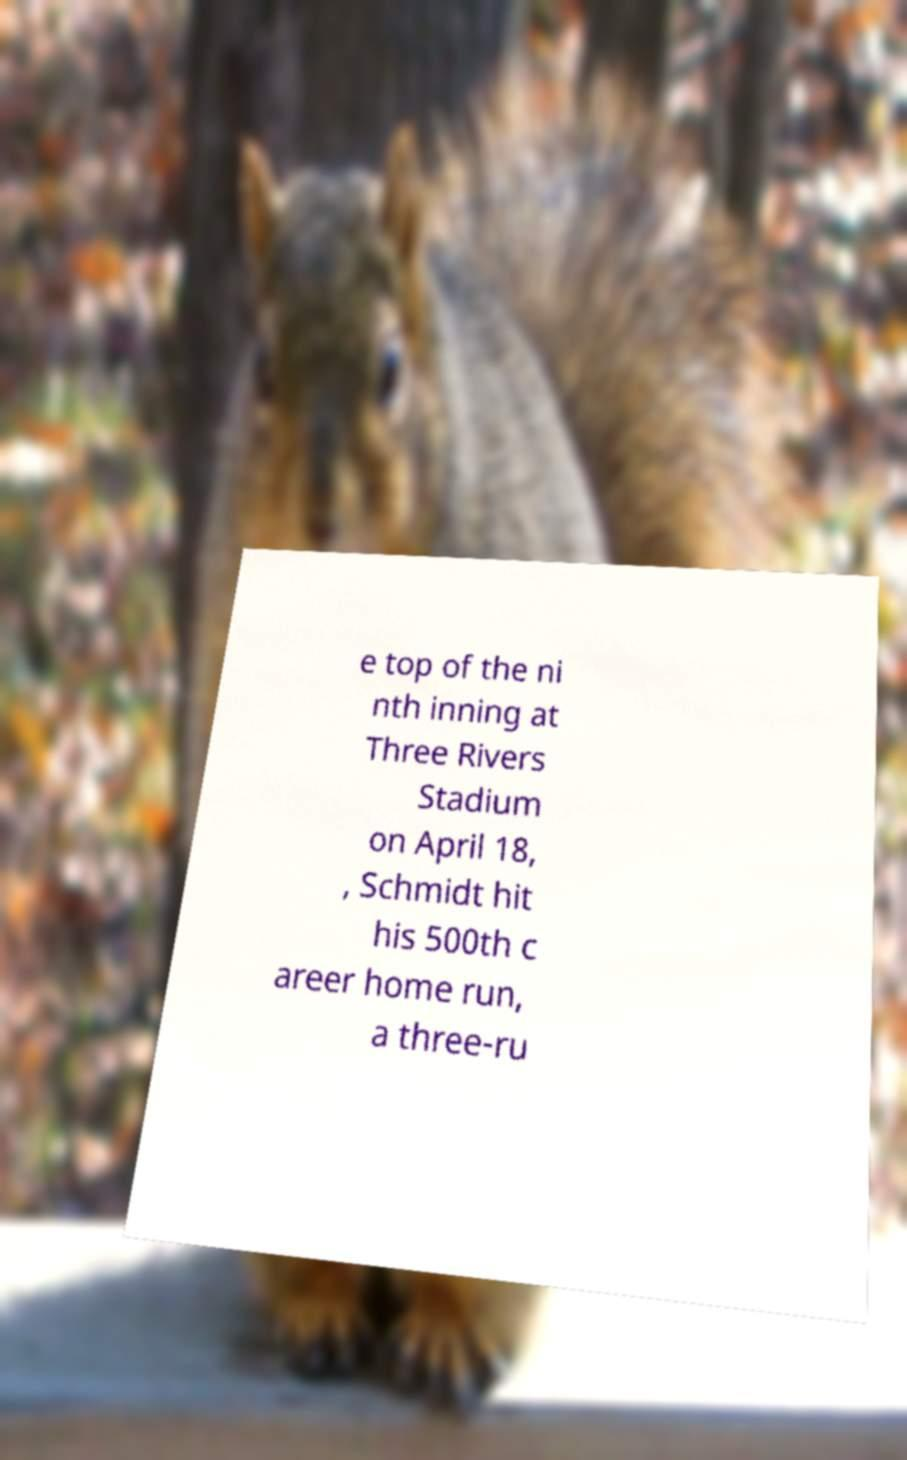I need the written content from this picture converted into text. Can you do that? e top of the ni nth inning at Three Rivers Stadium on April 18, , Schmidt hit his 500th c areer home run, a three-ru 